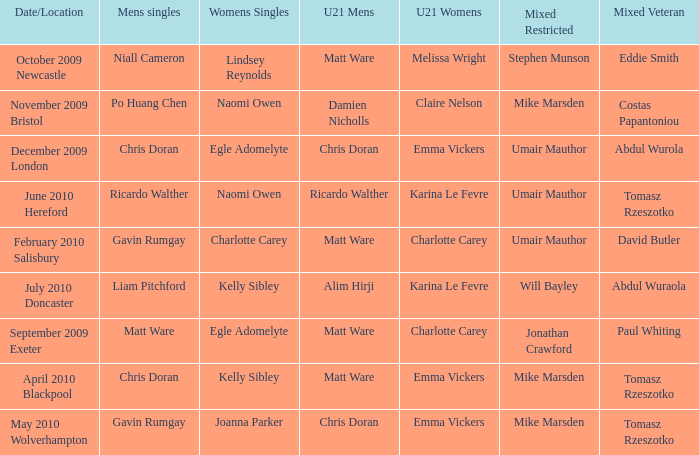When Naomi Owen won the Womens Singles and Ricardo Walther won the Mens Singles, who won the mixed veteran? Tomasz Rzeszotko. 